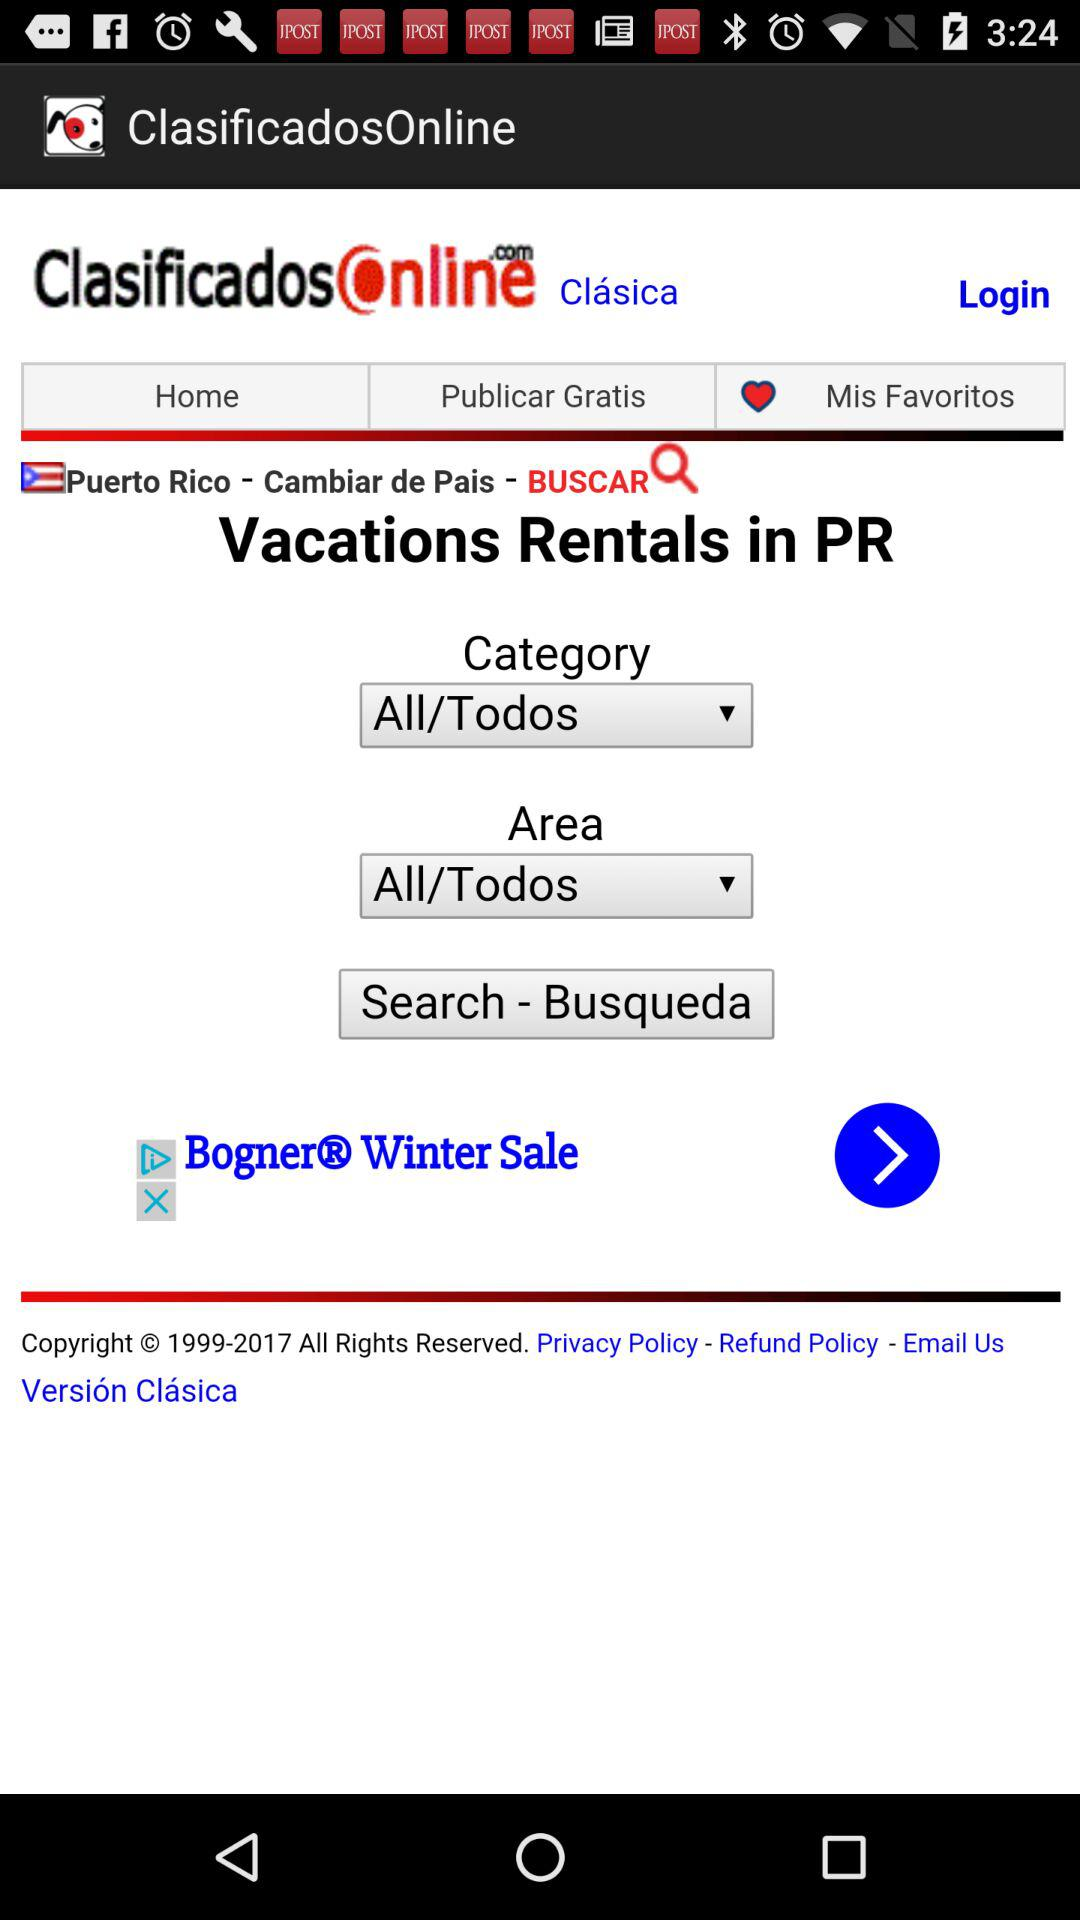What is the name of the application? The application name is "ClasificadosOnline". 